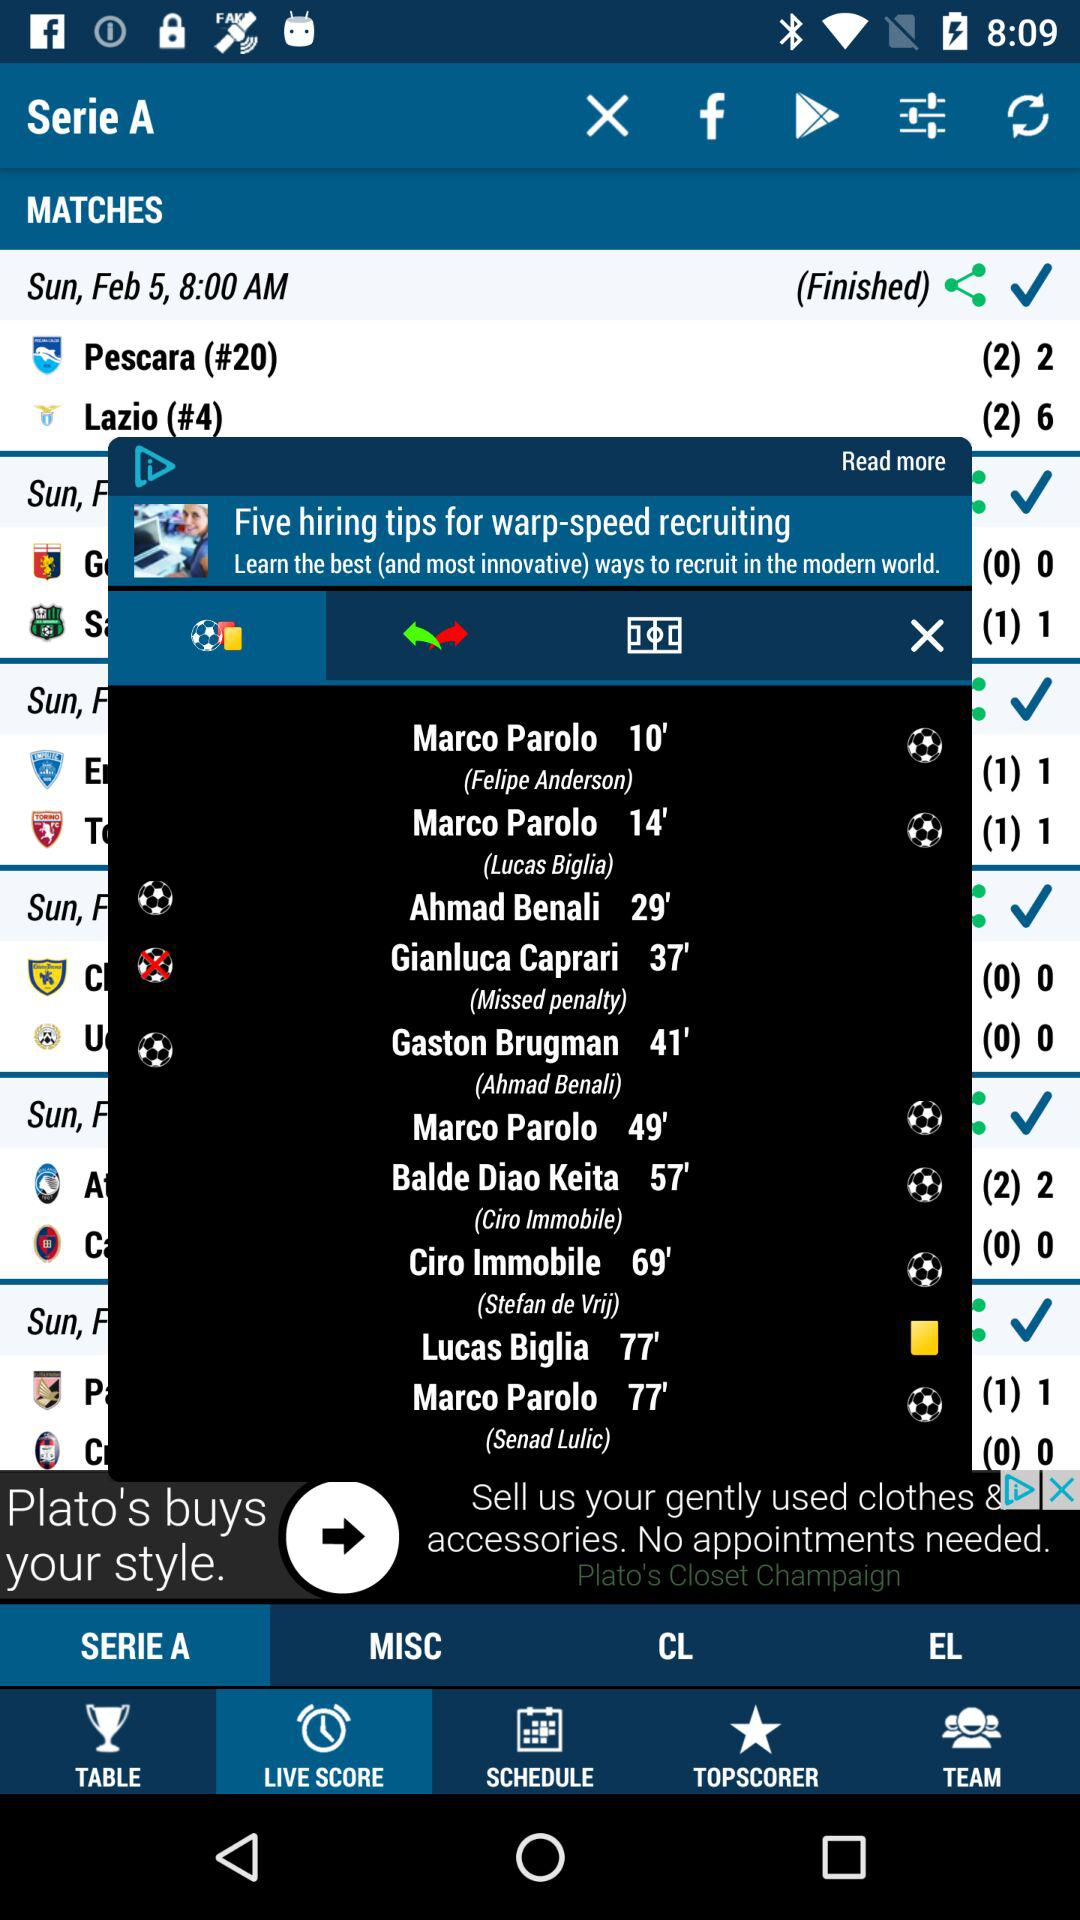Which tab is selected? The selected tabs are "SERIE A" and "LIVE SCORE". 